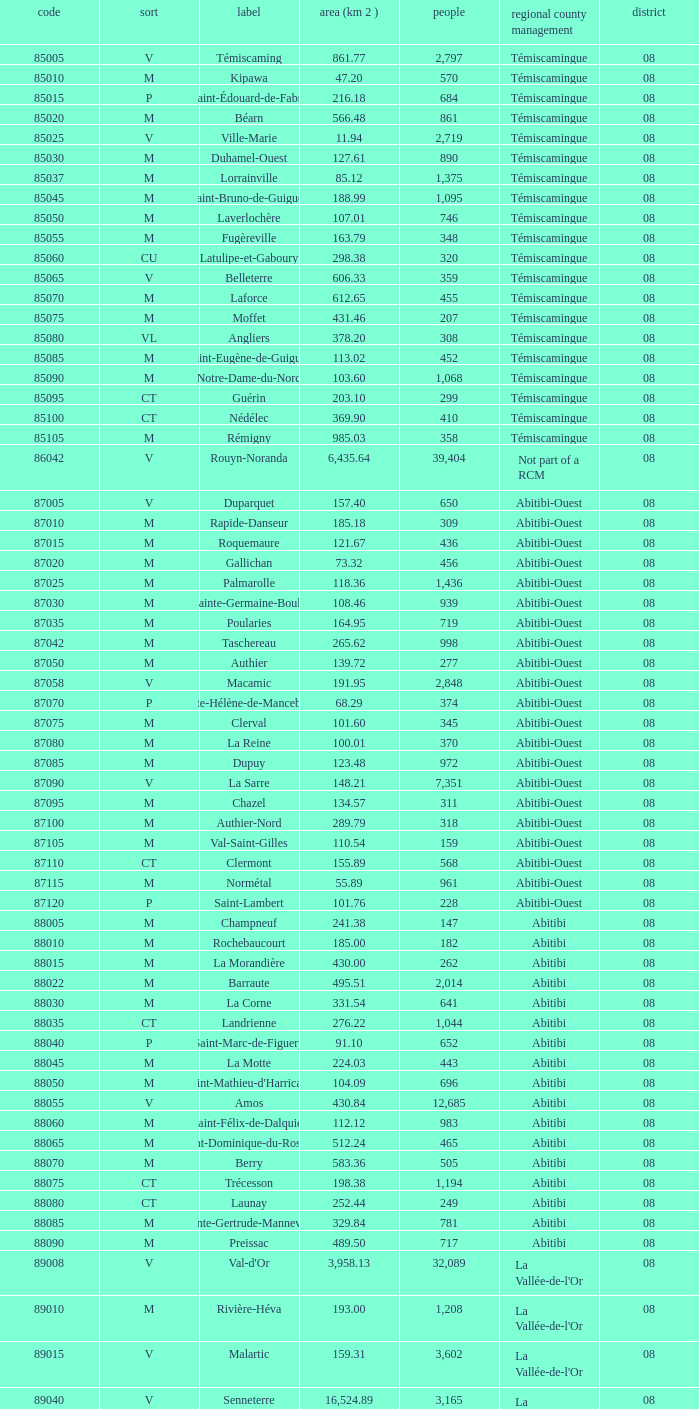Could you help me parse every detail presented in this table? {'header': ['code', 'sort', 'label', 'area (km 2 )', 'people', 'regional county management', 'district'], 'rows': [['85005', 'V', 'Témiscaming', '861.77', '2,797', 'Témiscamingue', '08'], ['85010', 'M', 'Kipawa', '47.20', '570', 'Témiscamingue', '08'], ['85015', 'P', 'Saint-Édouard-de-Fabre', '216.18', '684', 'Témiscamingue', '08'], ['85020', 'M', 'Béarn', '566.48', '861', 'Témiscamingue', '08'], ['85025', 'V', 'Ville-Marie', '11.94', '2,719', 'Témiscamingue', '08'], ['85030', 'M', 'Duhamel-Ouest', '127.61', '890', 'Témiscamingue', '08'], ['85037', 'M', 'Lorrainville', '85.12', '1,375', 'Témiscamingue', '08'], ['85045', 'M', 'Saint-Bruno-de-Guigues', '188.99', '1,095', 'Témiscamingue', '08'], ['85050', 'M', 'Laverlochère', '107.01', '746', 'Témiscamingue', '08'], ['85055', 'M', 'Fugèreville', '163.79', '348', 'Témiscamingue', '08'], ['85060', 'CU', 'Latulipe-et-Gaboury', '298.38', '320', 'Témiscamingue', '08'], ['85065', 'V', 'Belleterre', '606.33', '359', 'Témiscamingue', '08'], ['85070', 'M', 'Laforce', '612.65', '455', 'Témiscamingue', '08'], ['85075', 'M', 'Moffet', '431.46', '207', 'Témiscamingue', '08'], ['85080', 'VL', 'Angliers', '378.20', '308', 'Témiscamingue', '08'], ['85085', 'M', 'Saint-Eugène-de-Guigues', '113.02', '452', 'Témiscamingue', '08'], ['85090', 'M', 'Notre-Dame-du-Nord', '103.60', '1,068', 'Témiscamingue', '08'], ['85095', 'CT', 'Guérin', '203.10', '299', 'Témiscamingue', '08'], ['85100', 'CT', 'Nédélec', '369.90', '410', 'Témiscamingue', '08'], ['85105', 'M', 'Rémigny', '985.03', '358', 'Témiscamingue', '08'], ['86042', 'V', 'Rouyn-Noranda', '6,435.64', '39,404', 'Not part of a RCM', '08'], ['87005', 'V', 'Duparquet', '157.40', '650', 'Abitibi-Ouest', '08'], ['87010', 'M', 'Rapide-Danseur', '185.18', '309', 'Abitibi-Ouest', '08'], ['87015', 'M', 'Roquemaure', '121.67', '436', 'Abitibi-Ouest', '08'], ['87020', 'M', 'Gallichan', '73.32', '456', 'Abitibi-Ouest', '08'], ['87025', 'M', 'Palmarolle', '118.36', '1,436', 'Abitibi-Ouest', '08'], ['87030', 'M', 'Sainte-Germaine-Boulé', '108.46', '939', 'Abitibi-Ouest', '08'], ['87035', 'M', 'Poularies', '164.95', '719', 'Abitibi-Ouest', '08'], ['87042', 'M', 'Taschereau', '265.62', '998', 'Abitibi-Ouest', '08'], ['87050', 'M', 'Authier', '139.72', '277', 'Abitibi-Ouest', '08'], ['87058', 'V', 'Macamic', '191.95', '2,848', 'Abitibi-Ouest', '08'], ['87070', 'P', 'Sainte-Hélène-de-Mancebourg', '68.29', '374', 'Abitibi-Ouest', '08'], ['87075', 'M', 'Clerval', '101.60', '345', 'Abitibi-Ouest', '08'], ['87080', 'M', 'La Reine', '100.01', '370', 'Abitibi-Ouest', '08'], ['87085', 'M', 'Dupuy', '123.48', '972', 'Abitibi-Ouest', '08'], ['87090', 'V', 'La Sarre', '148.21', '7,351', 'Abitibi-Ouest', '08'], ['87095', 'M', 'Chazel', '134.57', '311', 'Abitibi-Ouest', '08'], ['87100', 'M', 'Authier-Nord', '289.79', '318', 'Abitibi-Ouest', '08'], ['87105', 'M', 'Val-Saint-Gilles', '110.54', '159', 'Abitibi-Ouest', '08'], ['87110', 'CT', 'Clermont', '155.89', '568', 'Abitibi-Ouest', '08'], ['87115', 'M', 'Normétal', '55.89', '961', 'Abitibi-Ouest', '08'], ['87120', 'P', 'Saint-Lambert', '101.76', '228', 'Abitibi-Ouest', '08'], ['88005', 'M', 'Champneuf', '241.38', '147', 'Abitibi', '08'], ['88010', 'M', 'Rochebaucourt', '185.00', '182', 'Abitibi', '08'], ['88015', 'M', 'La Morandière', '430.00', '262', 'Abitibi', '08'], ['88022', 'M', 'Barraute', '495.51', '2,014', 'Abitibi', '08'], ['88030', 'M', 'La Corne', '331.54', '641', 'Abitibi', '08'], ['88035', 'CT', 'Landrienne', '276.22', '1,044', 'Abitibi', '08'], ['88040', 'P', 'Saint-Marc-de-Figuery', '91.10', '652', 'Abitibi', '08'], ['88045', 'M', 'La Motte', '224.03', '443', 'Abitibi', '08'], ['88050', 'M', "Saint-Mathieu-d'Harricana", '104.09', '696', 'Abitibi', '08'], ['88055', 'V', 'Amos', '430.84', '12,685', 'Abitibi', '08'], ['88060', 'M', 'Saint-Félix-de-Dalquier', '112.12', '983', 'Abitibi', '08'], ['88065', 'M', 'Saint-Dominique-du-Rosaire', '512.24', '465', 'Abitibi', '08'], ['88070', 'M', 'Berry', '583.36', '505', 'Abitibi', '08'], ['88075', 'CT', 'Trécesson', '198.38', '1,194', 'Abitibi', '08'], ['88080', 'CT', 'Launay', '252.44', '249', 'Abitibi', '08'], ['88085', 'M', 'Sainte-Gertrude-Manneville', '329.84', '781', 'Abitibi', '08'], ['88090', 'M', 'Preissac', '489.50', '717', 'Abitibi', '08'], ['89008', 'V', "Val-d'Or", '3,958.13', '32,089', "La Vallée-de-l'Or", '08'], ['89010', 'M', 'Rivière-Héva', '193.00', '1,208', "La Vallée-de-l'Or", '08'], ['89015', 'V', 'Malartic', '159.31', '3,602', "La Vallée-de-l'Or", '08'], ['89040', 'V', 'Senneterre', '16,524.89', '3,165', "La Vallée-de-l'Or", '08'], ['89045', 'P', 'Senneterre', '432.98', '1,146', "La Vallée-de-l'Or", '08'], ['89050', 'M', 'Belcourt', '411.23', '261', "La Vallée-de-l'Or", '08']]} What was the region for Malartic with 159.31 km2? 0.0. 